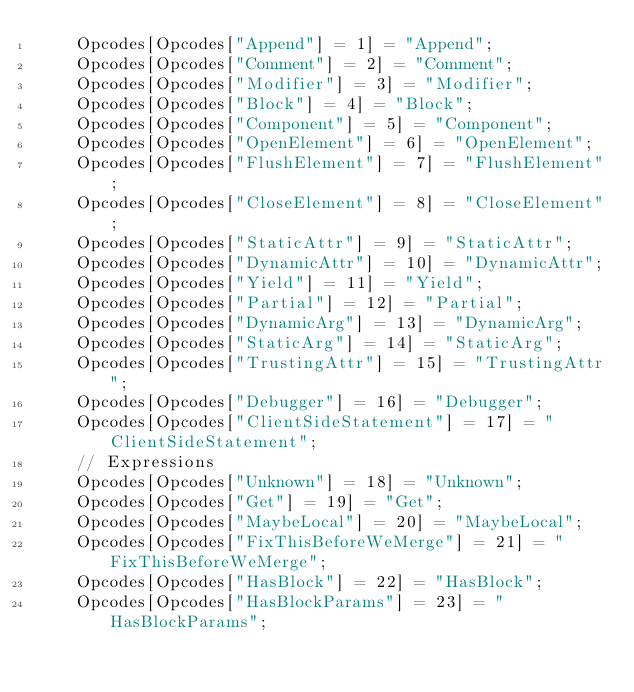<code> <loc_0><loc_0><loc_500><loc_500><_JavaScript_>    Opcodes[Opcodes["Append"] = 1] = "Append";
    Opcodes[Opcodes["Comment"] = 2] = "Comment";
    Opcodes[Opcodes["Modifier"] = 3] = "Modifier";
    Opcodes[Opcodes["Block"] = 4] = "Block";
    Opcodes[Opcodes["Component"] = 5] = "Component";
    Opcodes[Opcodes["OpenElement"] = 6] = "OpenElement";
    Opcodes[Opcodes["FlushElement"] = 7] = "FlushElement";
    Opcodes[Opcodes["CloseElement"] = 8] = "CloseElement";
    Opcodes[Opcodes["StaticAttr"] = 9] = "StaticAttr";
    Opcodes[Opcodes["DynamicAttr"] = 10] = "DynamicAttr";
    Opcodes[Opcodes["Yield"] = 11] = "Yield";
    Opcodes[Opcodes["Partial"] = 12] = "Partial";
    Opcodes[Opcodes["DynamicArg"] = 13] = "DynamicArg";
    Opcodes[Opcodes["StaticArg"] = 14] = "StaticArg";
    Opcodes[Opcodes["TrustingAttr"] = 15] = "TrustingAttr";
    Opcodes[Opcodes["Debugger"] = 16] = "Debugger";
    Opcodes[Opcodes["ClientSideStatement"] = 17] = "ClientSideStatement";
    // Expressions
    Opcodes[Opcodes["Unknown"] = 18] = "Unknown";
    Opcodes[Opcodes["Get"] = 19] = "Get";
    Opcodes[Opcodes["MaybeLocal"] = 20] = "MaybeLocal";
    Opcodes[Opcodes["FixThisBeforeWeMerge"] = 21] = "FixThisBeforeWeMerge";
    Opcodes[Opcodes["HasBlock"] = 22] = "HasBlock";
    Opcodes[Opcodes["HasBlockParams"] = 23] = "HasBlockParams";</code> 